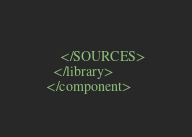<code> <loc_0><loc_0><loc_500><loc_500><_XML_>    </SOURCES>
  </library>
</component></code> 